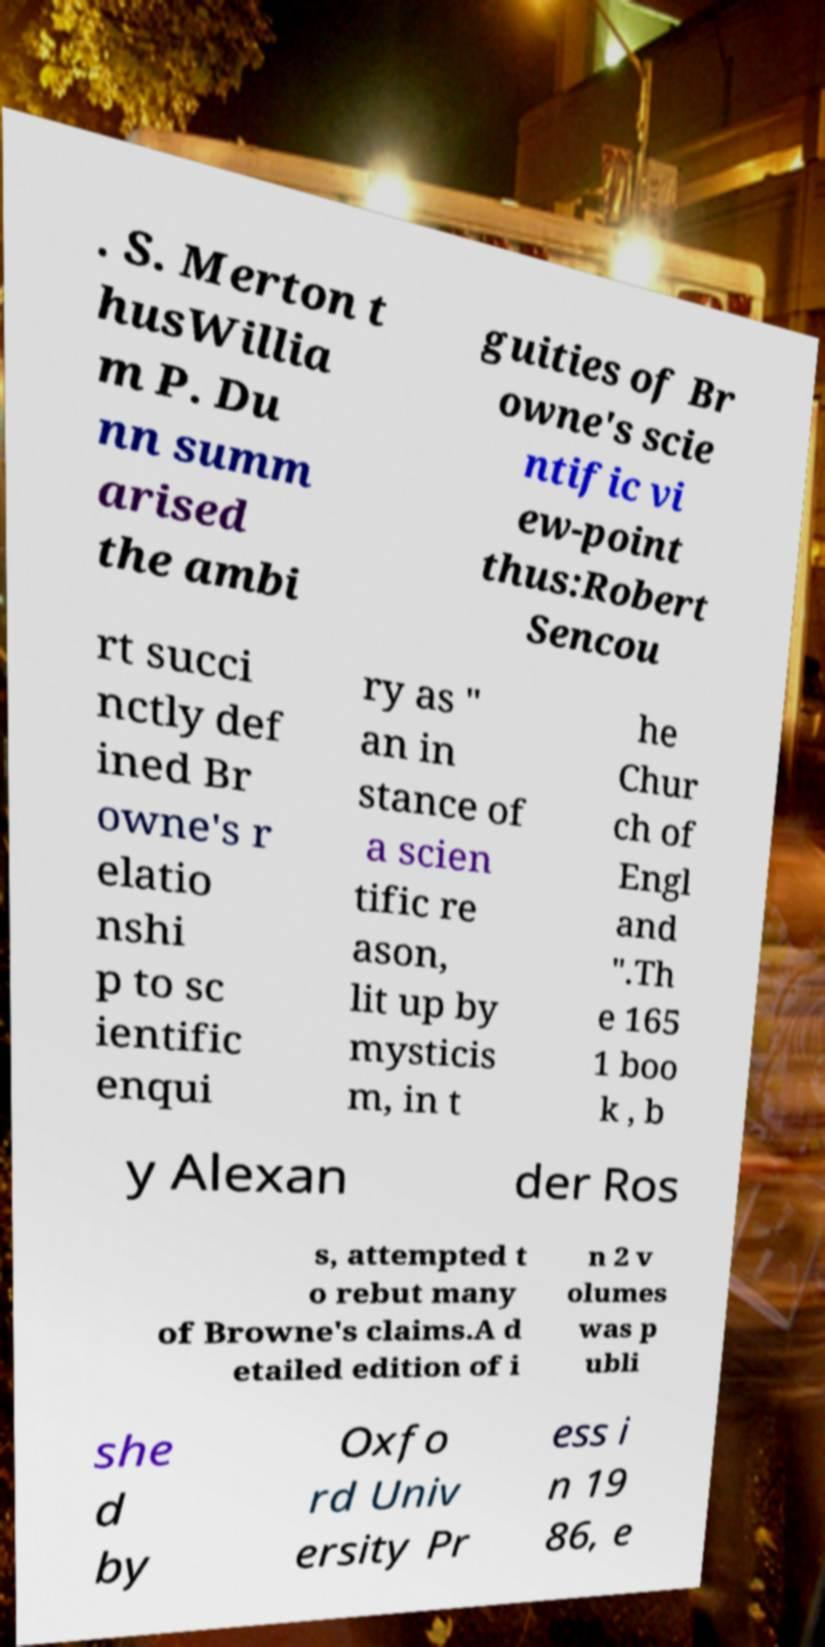Can you read and provide the text displayed in the image?This photo seems to have some interesting text. Can you extract and type it out for me? . S. Merton t husWillia m P. Du nn summ arised the ambi guities of Br owne's scie ntific vi ew-point thus:Robert Sencou rt succi nctly def ined Br owne's r elatio nshi p to sc ientific enqui ry as " an in stance of a scien tific re ason, lit up by mysticis m, in t he Chur ch of Engl and ".Th e 165 1 boo k , b y Alexan der Ros s, attempted t o rebut many of Browne's claims.A d etailed edition of i n 2 v olumes was p ubli she d by Oxfo rd Univ ersity Pr ess i n 19 86, e 